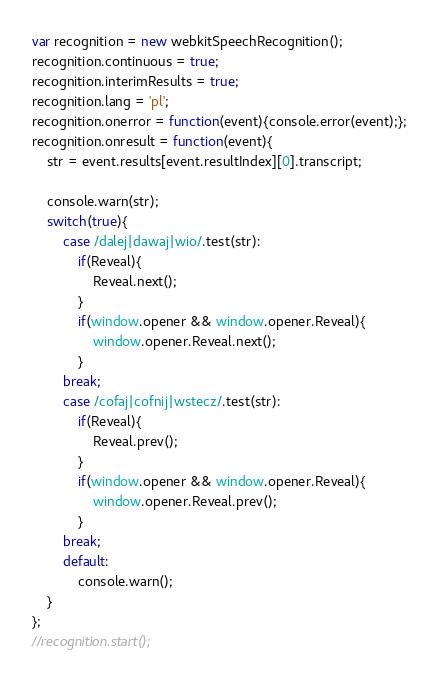<code> <loc_0><loc_0><loc_500><loc_500><_JavaScript_>var recognition = new webkitSpeechRecognition();
recognition.continuous = true;
recognition.interimResults = true;
recognition.lang = 'pl';
recognition.onerror = function(event){console.error(event);};
recognition.onresult = function(event){
    str = event.results[event.resultIndex][0].transcript;

    console.warn(str);
    switch(true){
        case /dalej|dawaj|wio/.test(str):
            if(Reveal){
                Reveal.next();
            }
            if(window.opener && window.opener.Reveal){
                window.opener.Reveal.next();
            }
        break;
        case /cofaj|cofnij|wstecz/.test(str):
            if(Reveal){
                Reveal.prev();
            }
            if(window.opener && window.opener.Reveal){
                window.opener.Reveal.prev();
            }
        break;
        default:
            console.warn();
    }
};
//recognition.start();
</code> 